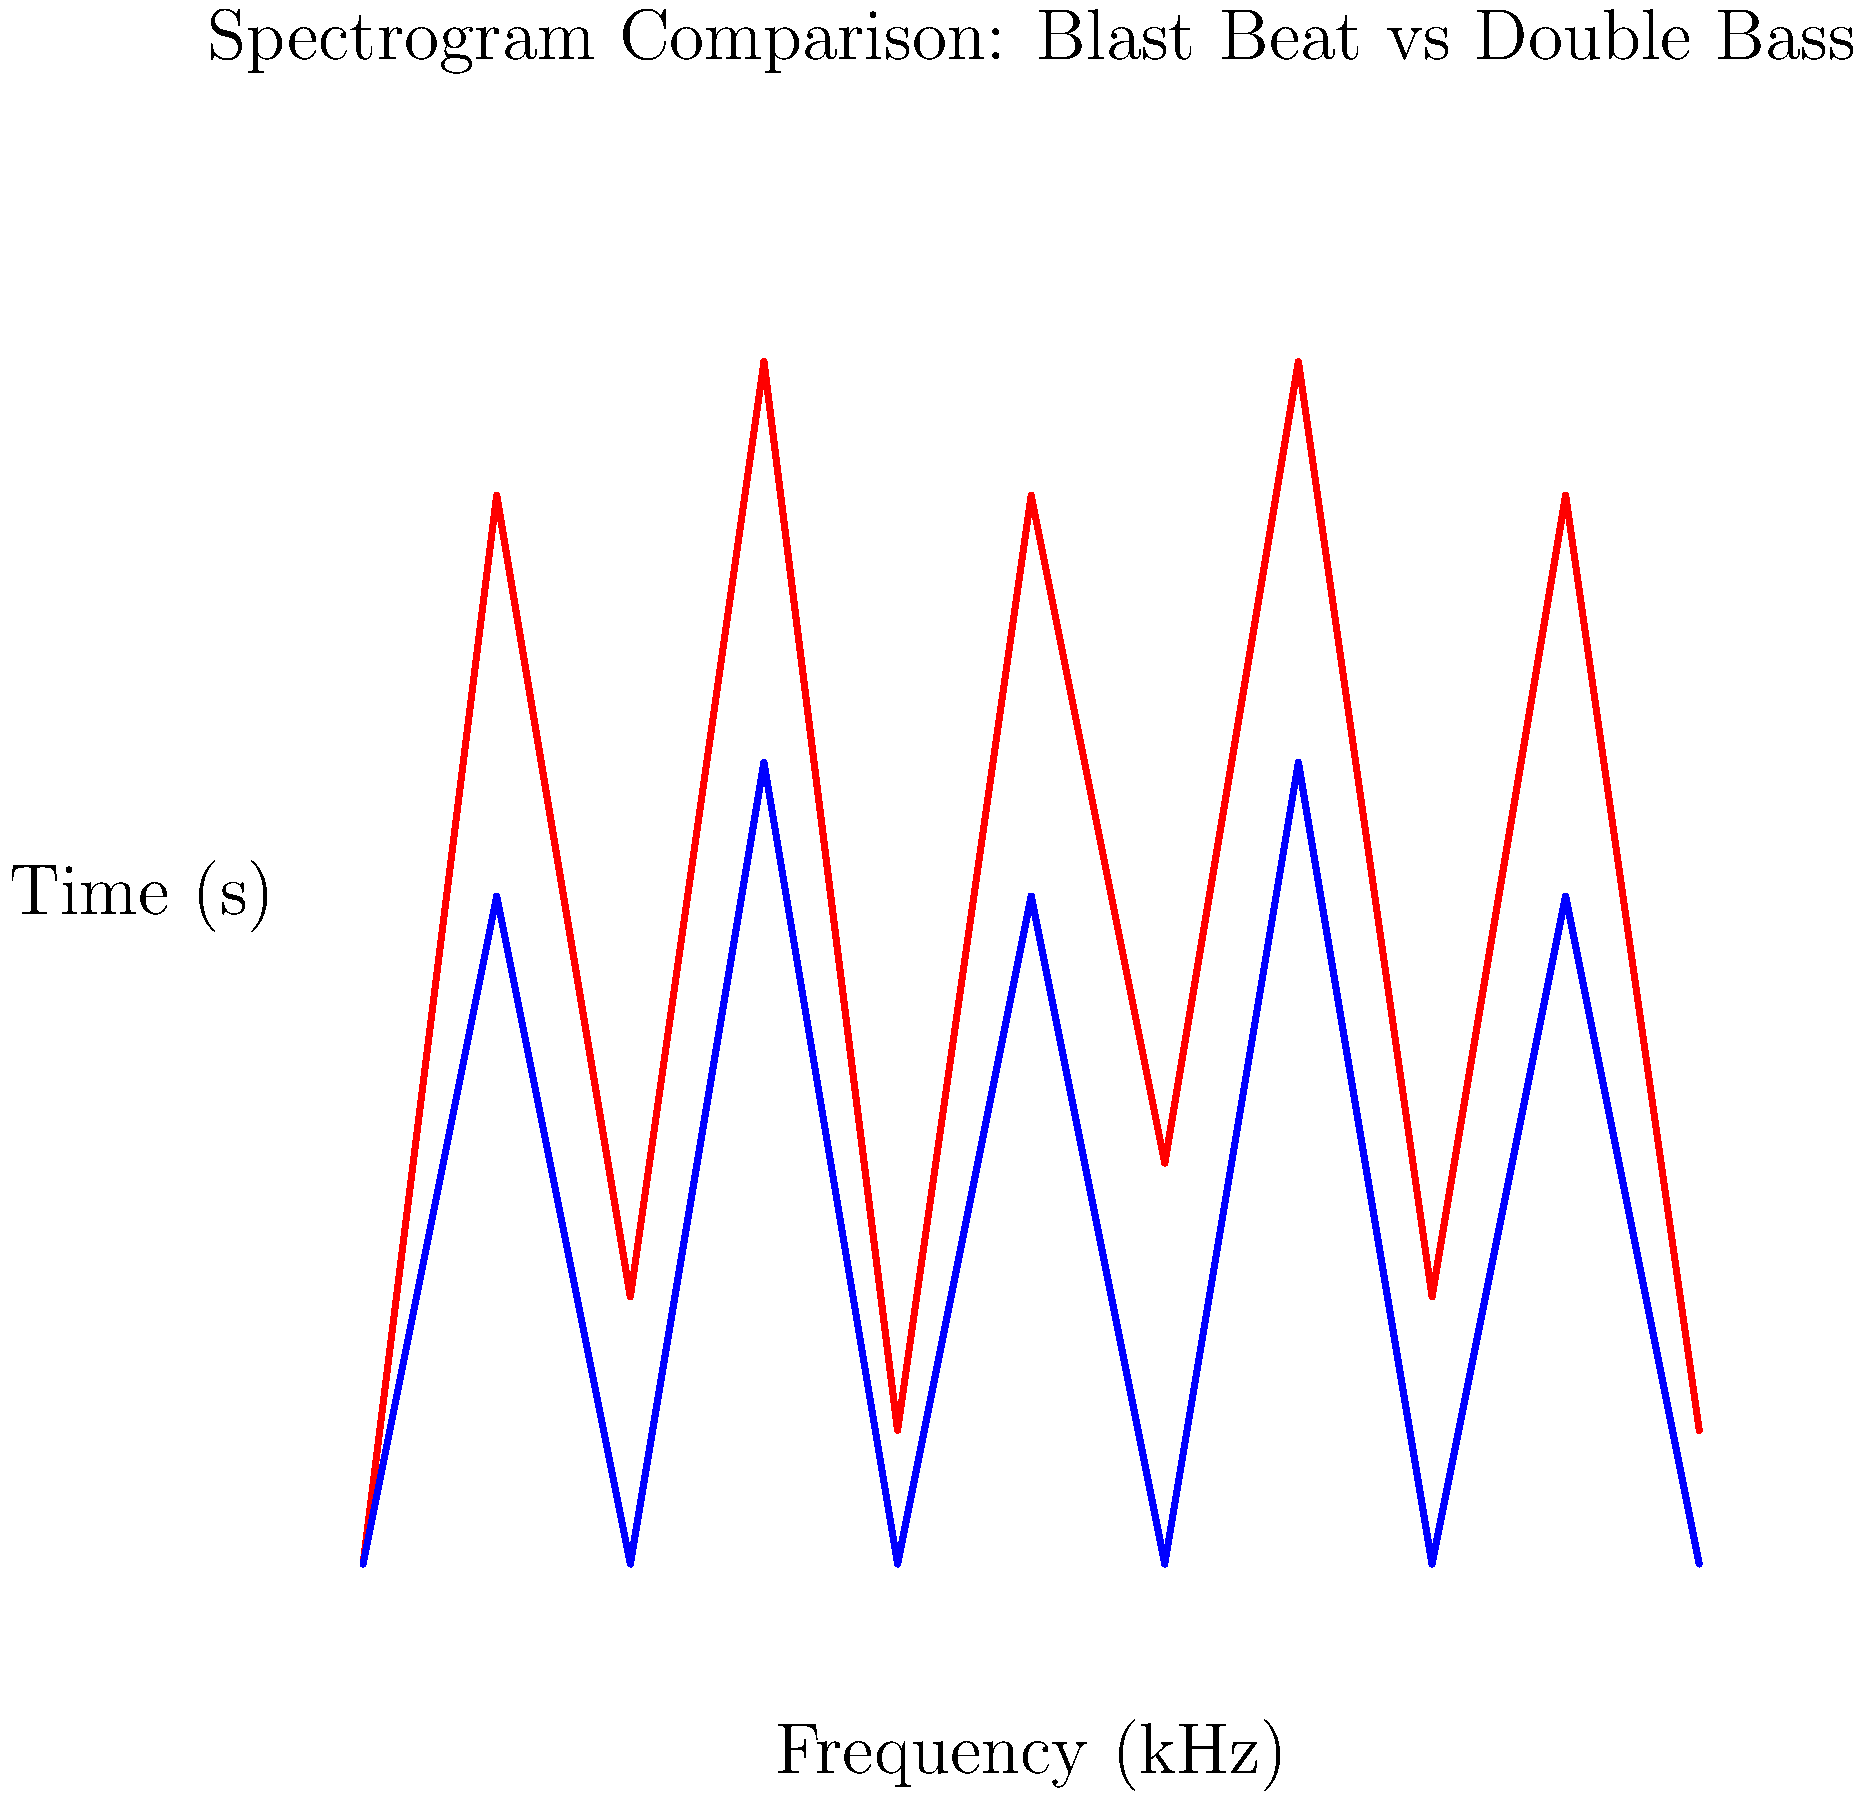Analyze the spectrogram comparison of blast beat and double bass drumming techniques in metal music. Which technique exhibits a higher average frequency and more rapid alternation between high and low frequencies? To answer this question, we need to analyze the spectrogram comparison provided:

1. Frequency range:
   - The y-axis represents frequency in kHz.
   - Both techniques show variations in frequency over time.

2. Blast Beat (red line):
   - Exhibits rapid alternations between high and low frequencies.
   - Reaches higher peak frequencies (around 9 kHz).
   - Shows more frequent and extreme fluctuations.

3. Double Bass (blue line):
   - Shows a more regular pattern of alternating frequencies.
   - Peak frequencies are lower (around 6 kHz).
   - Fluctuations are less extreme and occur at a slower rate.

4. Average frequency:
   - Blast Beat appears to have a higher average frequency due to its higher peaks and more frequent high-frequency components.

5. Rapid alternation:
   - Blast Beat shows more rapid alternations between high and low frequencies, as evidenced by the more frequent peaks and valleys in the red line.

Based on this analysis, the Blast Beat technique demonstrates both a higher average frequency and more rapid alternation between high and low frequencies compared to the Double Bass technique.
Answer: Blast Beat 